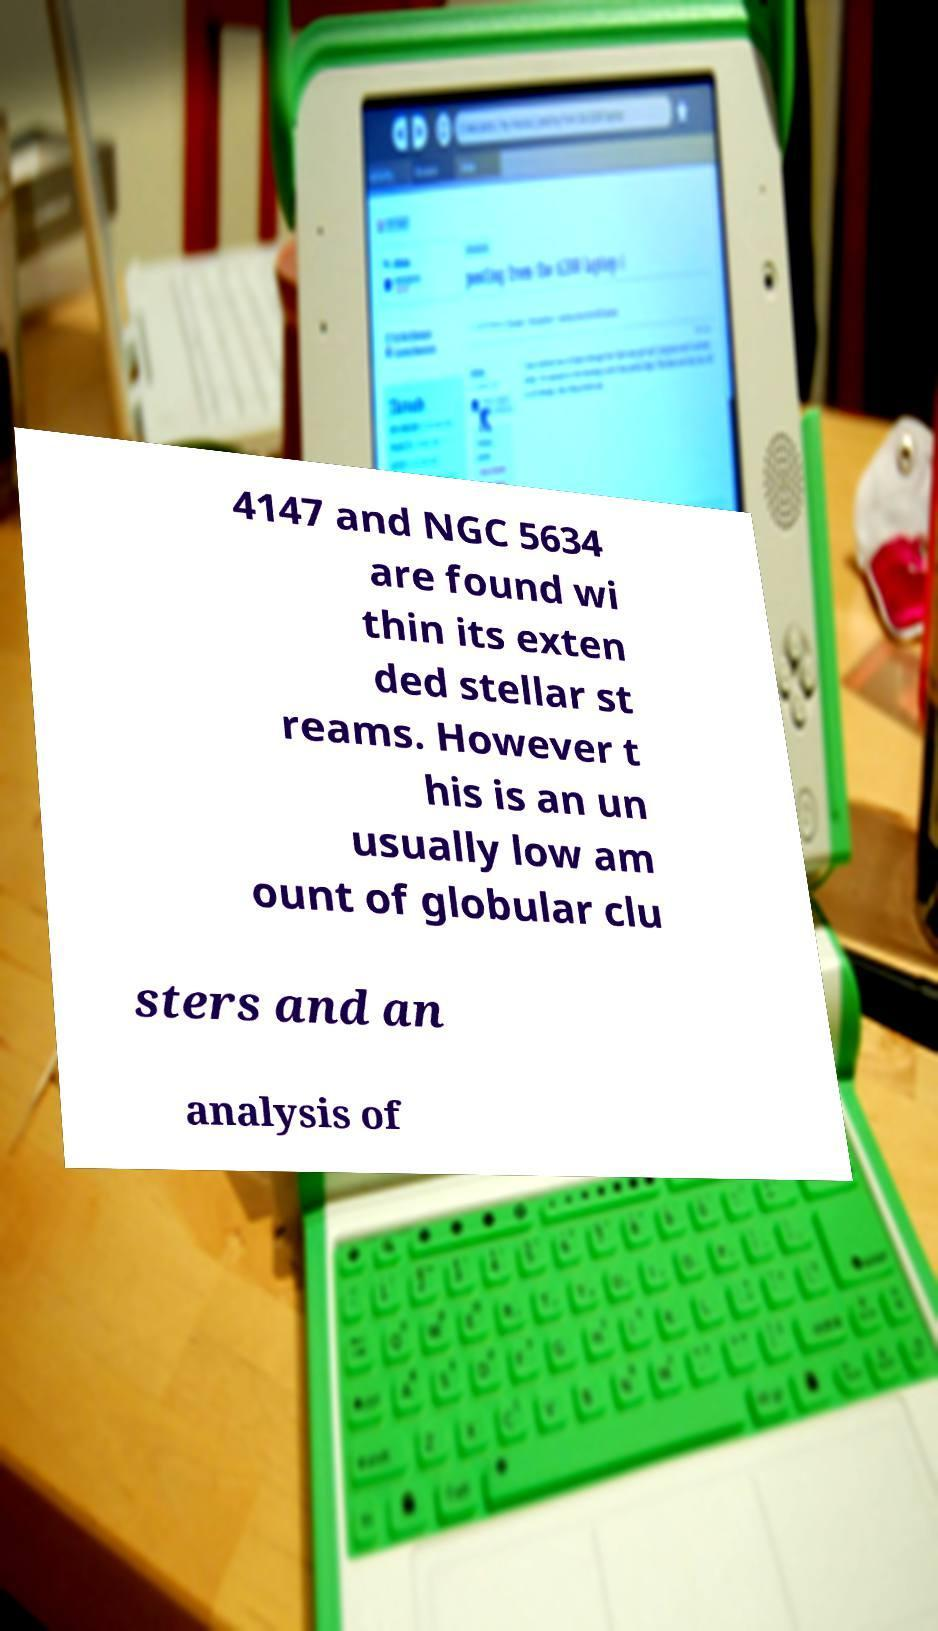Could you assist in decoding the text presented in this image and type it out clearly? 4147 and NGC 5634 are found wi thin its exten ded stellar st reams. However t his is an un usually low am ount of globular clu sters and an analysis of 